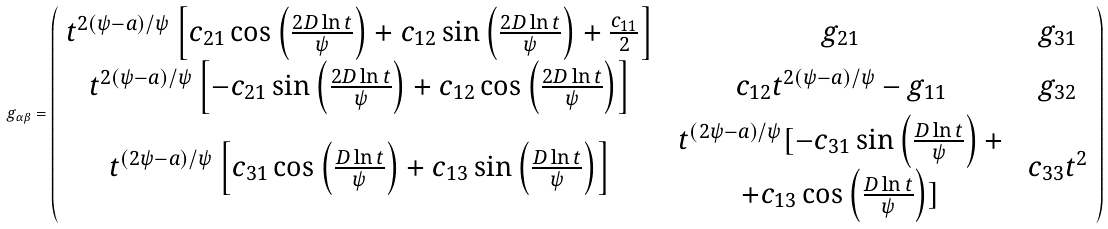<formula> <loc_0><loc_0><loc_500><loc_500>g _ { \alpha \beta } = \left ( \begin{array} { c c c } t ^ { 2 ( \psi - a ) / \psi } \left [ c _ { 2 1 } \cos \left ( \frac { 2 D \ln t } \psi \right ) + c _ { 1 2 } \sin \left ( \frac { 2 D \ln t } \psi \right ) + \frac { c _ { 1 1 } } 2 \right ] & g _ { 2 1 } & g _ { 3 1 } \\ t ^ { 2 ( \psi - a ) / \psi } \left [ - c _ { 2 1 } \sin \left ( \frac { 2 D \ln t } \psi \right ) + c _ { 1 2 } \cos \left ( \frac { 2 D \ln t } \psi \right ) \right ] & c _ { 1 2 } t ^ { 2 ( \psi - a ) / \psi } - g _ { 1 1 } & g _ { 3 2 } \\ t ^ { ( 2 \psi - a ) / \psi } \left [ c _ { 3 1 } \cos \left ( \frac { D \ln t } \psi \right ) + c _ { 1 3 } \sin \left ( \frac { D \ln t } \psi \right ) \right ] & \begin{array} { c } t ^ { ( 2 \psi - a ) / \psi } [ - c _ { 3 1 } \sin \left ( \frac { D \ln t } \psi \right ) + \\ + c _ { 1 3 } \cos \left ( \frac { D \ln t } \psi \right ) ] \end{array} & c _ { 3 3 } t ^ { 2 } \end{array} \right )</formula> 